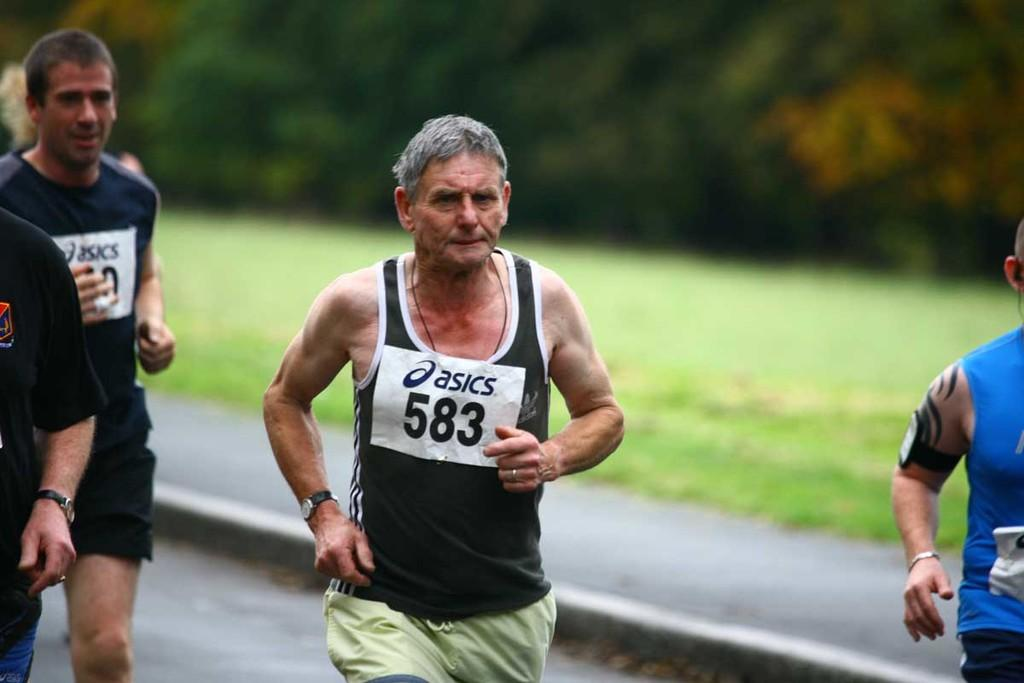What are the persons in the image doing? The persons in the image are running. What can be seen in the background of the image? There is a road, trees, and grass on the ground in the background of the image. Where is the goat located in the image? There is no goat present in the image. How many fifths can be seen in the image? The concept of "fifths" does not apply to the image, as it is not a fraction or division of any element in the image. 